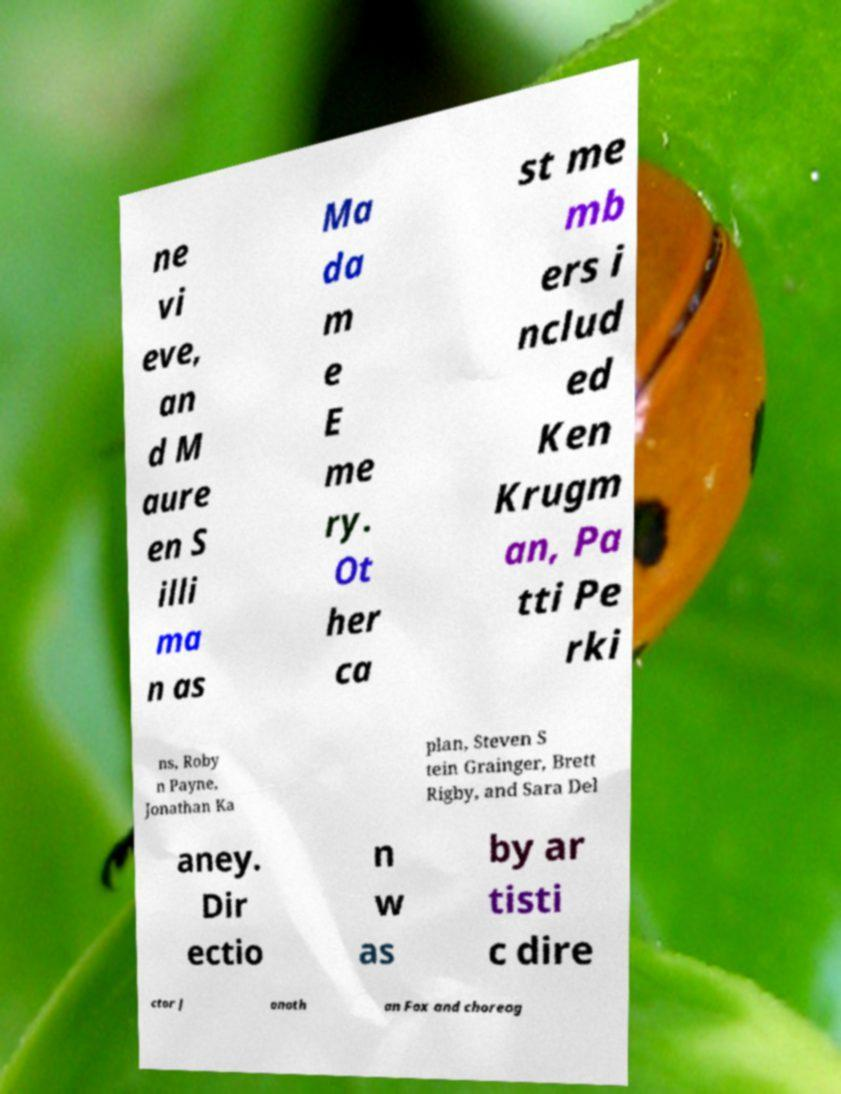I need the written content from this picture converted into text. Can you do that? ne vi eve, an d M aure en S illi ma n as Ma da m e E me ry. Ot her ca st me mb ers i nclud ed Ken Krugm an, Pa tti Pe rki ns, Roby n Payne, Jonathan Ka plan, Steven S tein Grainger, Brett Rigby, and Sara Del aney. Dir ectio n w as by ar tisti c dire ctor J onath an Fox and choreog 